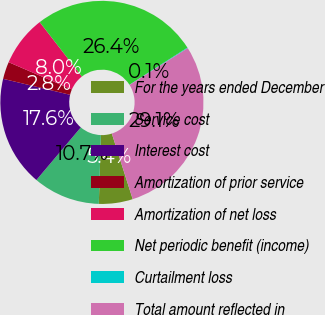Convert chart. <chart><loc_0><loc_0><loc_500><loc_500><pie_chart><fcel>For the years ended December<fcel>Service cost<fcel>Interest cost<fcel>Amortization of prior service<fcel>Amortization of net loss<fcel>Net periodic benefit (income)<fcel>Curtailment loss<fcel>Total amount reflected in<nl><fcel>5.39%<fcel>10.67%<fcel>17.57%<fcel>2.75%<fcel>8.03%<fcel>26.42%<fcel>0.1%<fcel>29.06%<nl></chart> 